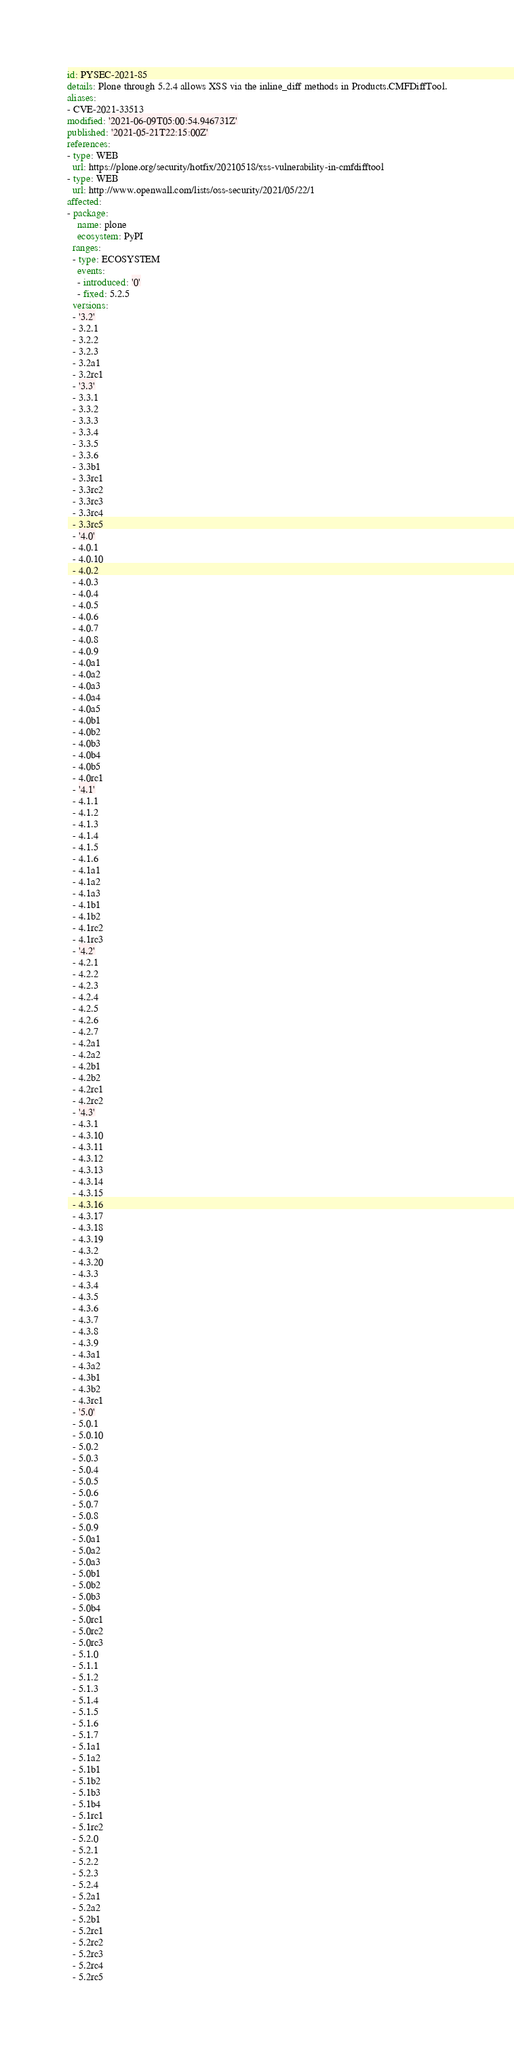Convert code to text. <code><loc_0><loc_0><loc_500><loc_500><_YAML_>id: PYSEC-2021-85
details: Plone through 5.2.4 allows XSS via the inline_diff methods in Products.CMFDiffTool.
aliases:
- CVE-2021-33513
modified: '2021-06-09T05:00:54.946731Z'
published: '2021-05-21T22:15:00Z'
references:
- type: WEB
  url: https://plone.org/security/hotfix/20210518/xss-vulnerability-in-cmfdifftool
- type: WEB
  url: http://www.openwall.com/lists/oss-security/2021/05/22/1
affected:
- package:
    name: plone
    ecosystem: PyPI
  ranges:
  - type: ECOSYSTEM
    events:
    - introduced: '0'
    - fixed: 5.2.5
  versions:
  - '3.2'
  - 3.2.1
  - 3.2.2
  - 3.2.3
  - 3.2a1
  - 3.2rc1
  - '3.3'
  - 3.3.1
  - 3.3.2
  - 3.3.3
  - 3.3.4
  - 3.3.5
  - 3.3.6
  - 3.3b1
  - 3.3rc1
  - 3.3rc2
  - 3.3rc3
  - 3.3rc4
  - 3.3rc5
  - '4.0'
  - 4.0.1
  - 4.0.10
  - 4.0.2
  - 4.0.3
  - 4.0.4
  - 4.0.5
  - 4.0.6
  - 4.0.7
  - 4.0.8
  - 4.0.9
  - 4.0a1
  - 4.0a2
  - 4.0a3
  - 4.0a4
  - 4.0a5
  - 4.0b1
  - 4.0b2
  - 4.0b3
  - 4.0b4
  - 4.0b5
  - 4.0rc1
  - '4.1'
  - 4.1.1
  - 4.1.2
  - 4.1.3
  - 4.1.4
  - 4.1.5
  - 4.1.6
  - 4.1a1
  - 4.1a2
  - 4.1a3
  - 4.1b1
  - 4.1b2
  - 4.1rc2
  - 4.1rc3
  - '4.2'
  - 4.2.1
  - 4.2.2
  - 4.2.3
  - 4.2.4
  - 4.2.5
  - 4.2.6
  - 4.2.7
  - 4.2a1
  - 4.2a2
  - 4.2b1
  - 4.2b2
  - 4.2rc1
  - 4.2rc2
  - '4.3'
  - 4.3.1
  - 4.3.10
  - 4.3.11
  - 4.3.12
  - 4.3.13
  - 4.3.14
  - 4.3.15
  - 4.3.16
  - 4.3.17
  - 4.3.18
  - 4.3.19
  - 4.3.2
  - 4.3.20
  - 4.3.3
  - 4.3.4
  - 4.3.5
  - 4.3.6
  - 4.3.7
  - 4.3.8
  - 4.3.9
  - 4.3a1
  - 4.3a2
  - 4.3b1
  - 4.3b2
  - 4.3rc1
  - '5.0'
  - 5.0.1
  - 5.0.10
  - 5.0.2
  - 5.0.3
  - 5.0.4
  - 5.0.5
  - 5.0.6
  - 5.0.7
  - 5.0.8
  - 5.0.9
  - 5.0a1
  - 5.0a2
  - 5.0a3
  - 5.0b1
  - 5.0b2
  - 5.0b3
  - 5.0b4
  - 5.0rc1
  - 5.0rc2
  - 5.0rc3
  - 5.1.0
  - 5.1.1
  - 5.1.2
  - 5.1.3
  - 5.1.4
  - 5.1.5
  - 5.1.6
  - 5.1.7
  - 5.1a1
  - 5.1a2
  - 5.1b1
  - 5.1b2
  - 5.1b3
  - 5.1b4
  - 5.1rc1
  - 5.1rc2
  - 5.2.0
  - 5.2.1
  - 5.2.2
  - 5.2.3
  - 5.2.4
  - 5.2a1
  - 5.2a2
  - 5.2b1
  - 5.2rc1
  - 5.2rc2
  - 5.2rc3
  - 5.2rc4
  - 5.2rc5
</code> 